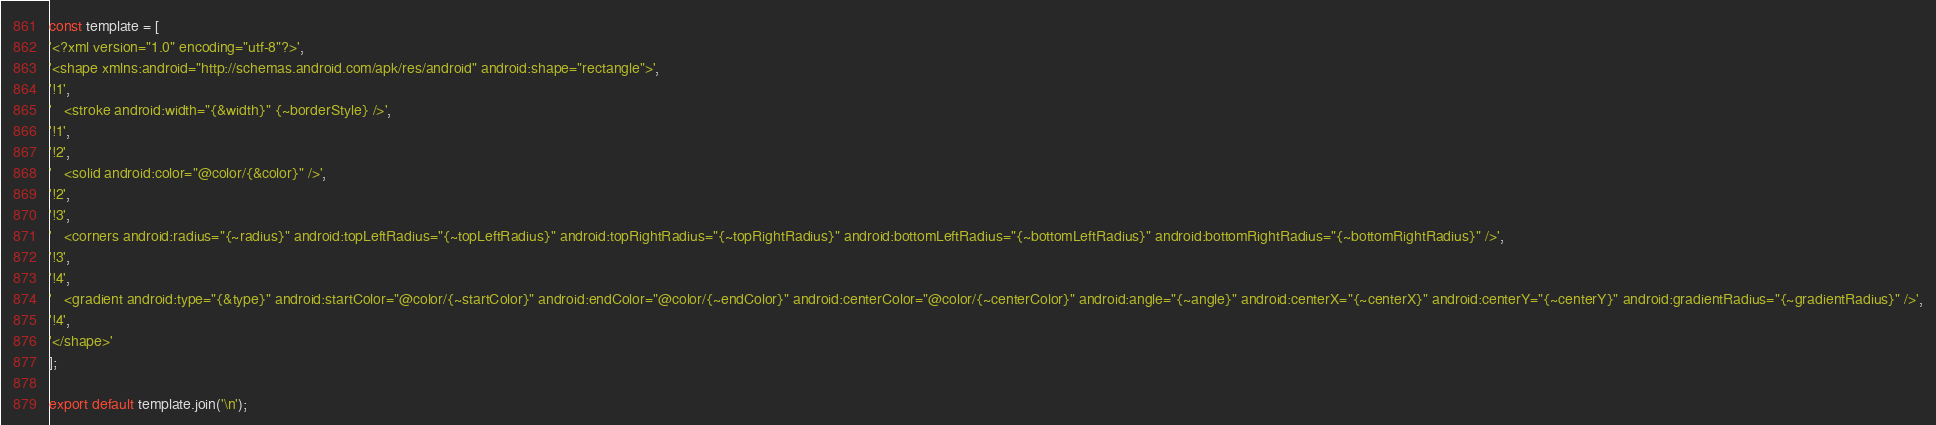Convert code to text. <code><loc_0><loc_0><loc_500><loc_500><_TypeScript_>const template = [
'<?xml version="1.0" encoding="utf-8"?>',
'<shape xmlns:android="http://schemas.android.com/apk/res/android" android:shape="rectangle">',
'!1',
'	<stroke android:width="{&width}" {~borderStyle} />',
'!1',
'!2',
'	<solid android:color="@color/{&color}" />',
'!2',
'!3',
'	<corners android:radius="{~radius}" android:topLeftRadius="{~topLeftRadius}" android:topRightRadius="{~topRightRadius}" android:bottomLeftRadius="{~bottomLeftRadius}" android:bottomRightRadius="{~bottomRightRadius}" />',
'!3',
'!4',
'	<gradient android:type="{&type}" android:startColor="@color/{~startColor}" android:endColor="@color/{~endColor}" android:centerColor="@color/{~centerColor}" android:angle="{~angle}" android:centerX="{~centerX}" android:centerY="{~centerY}" android:gradientRadius="{~gradientRadius}" />',
'!4',
'</shape>'
];

export default template.join('\n');</code> 